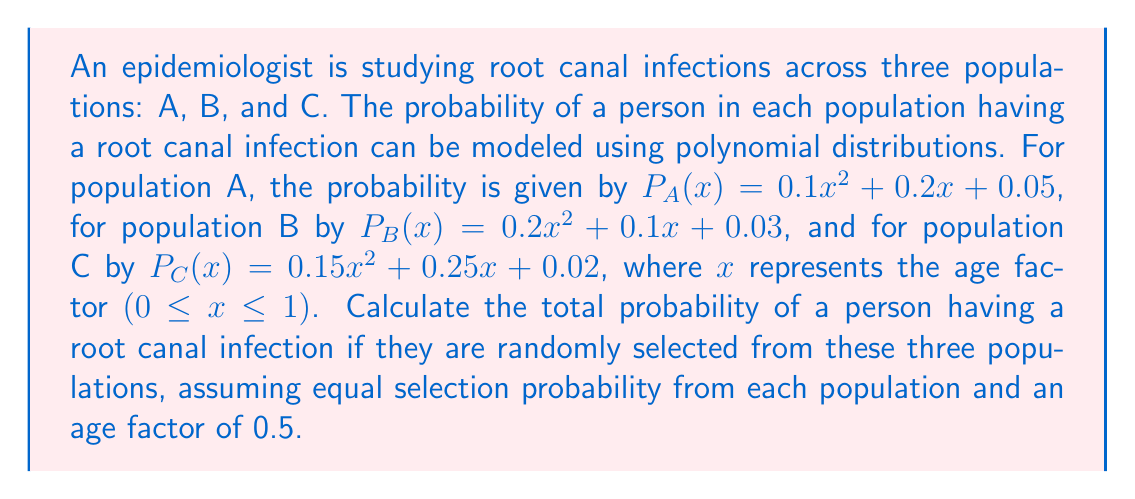Show me your answer to this math problem. To solve this problem, we need to follow these steps:

1. Calculate the probability for each population at x = 0.5:

For population A:
$P_A(0.5) = 0.1(0.5)^2 + 0.2(0.5) + 0.05$
$= 0.1(0.25) + 0.1 + 0.05$
$= 0.025 + 0.1 + 0.05 = 0.175$

For population B:
$P_B(0.5) = 0.2(0.5)^2 + 0.1(0.5) + 0.03$
$= 0.2(0.25) + 0.05 + 0.03$
$= 0.05 + 0.05 + 0.03 = 0.13$

For population C:
$P_C(0.5) = 0.15(0.5)^2 + 0.25(0.5) + 0.02$
$= 0.15(0.25) + 0.125 + 0.02$
$= 0.0375 + 0.125 + 0.02 = 0.1825$

2. Calculate the average probability across all three populations:

Since the person is equally likely to be selected from each population, we can take the arithmetic mean of the three probabilities:

$P_{total} = \frac{P_A(0.5) + P_B(0.5) + P_C(0.5)}{3}$

$P_{total} = \frac{0.175 + 0.13 + 0.1825}{3}$

$P_{total} = \frac{0.4875}{3} = 0.1625$

Therefore, the total probability of a randomly selected person having a root canal infection is 0.1625 or 16.25%.
Answer: 0.1625 